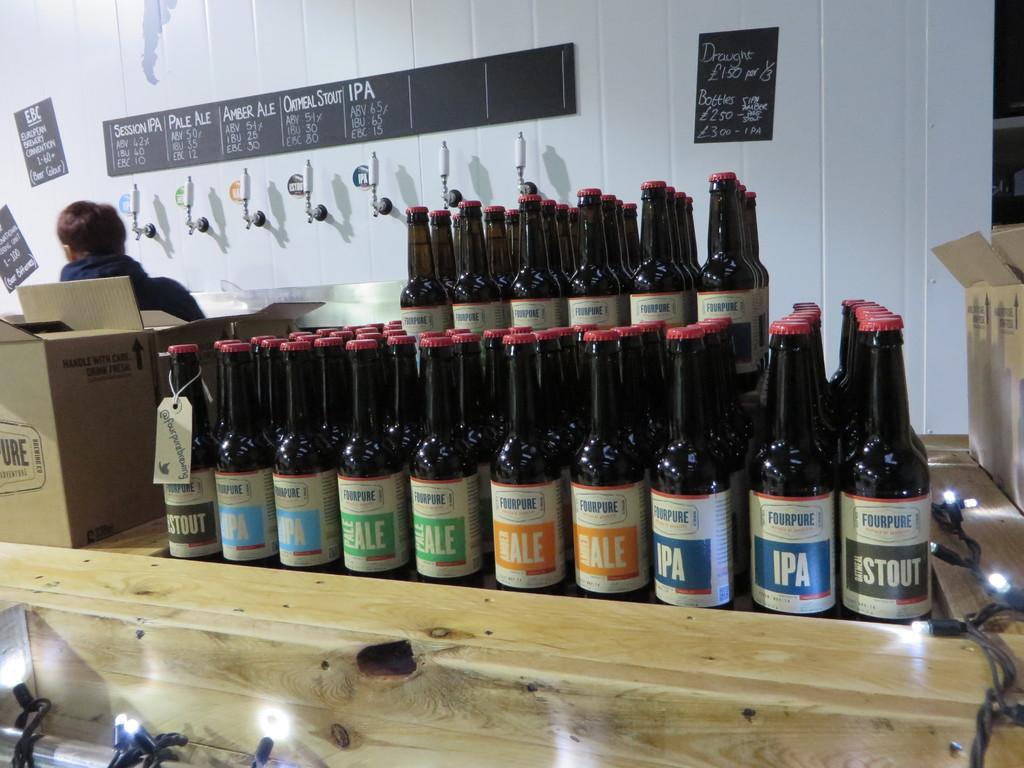Describe this image in one or two sentences. In this image we can see bottles with labels on it placed on the table. In the background we can see boxes and a person standing near the wall. 